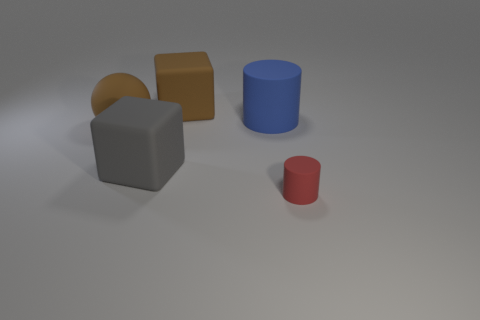There is a matte block that is the same color as the rubber ball; what is its size?
Offer a terse response. Large. What is the shape of the small rubber thing?
Your answer should be compact. Cylinder. Are there any cylinders behind the matte ball?
Give a very brief answer. Yes. Does the tiny red cylinder have the same material as the big block in front of the brown matte block?
Your answer should be very brief. Yes. There is a brown object that is on the right side of the gray thing; does it have the same shape as the large gray matte thing?
Your response must be concise. Yes. What number of other large cylinders have the same material as the blue cylinder?
Ensure brevity in your answer.  0. How many objects are either matte objects to the left of the tiny red matte cylinder or large blue cylinders?
Ensure brevity in your answer.  4. The brown rubber ball has what size?
Offer a terse response. Large. There is a cylinder behind the large rubber object that is left of the large gray thing; what is it made of?
Your answer should be very brief. Rubber. Does the brown rubber thing right of the brown rubber ball have the same size as the tiny matte object?
Offer a very short reply. No. 